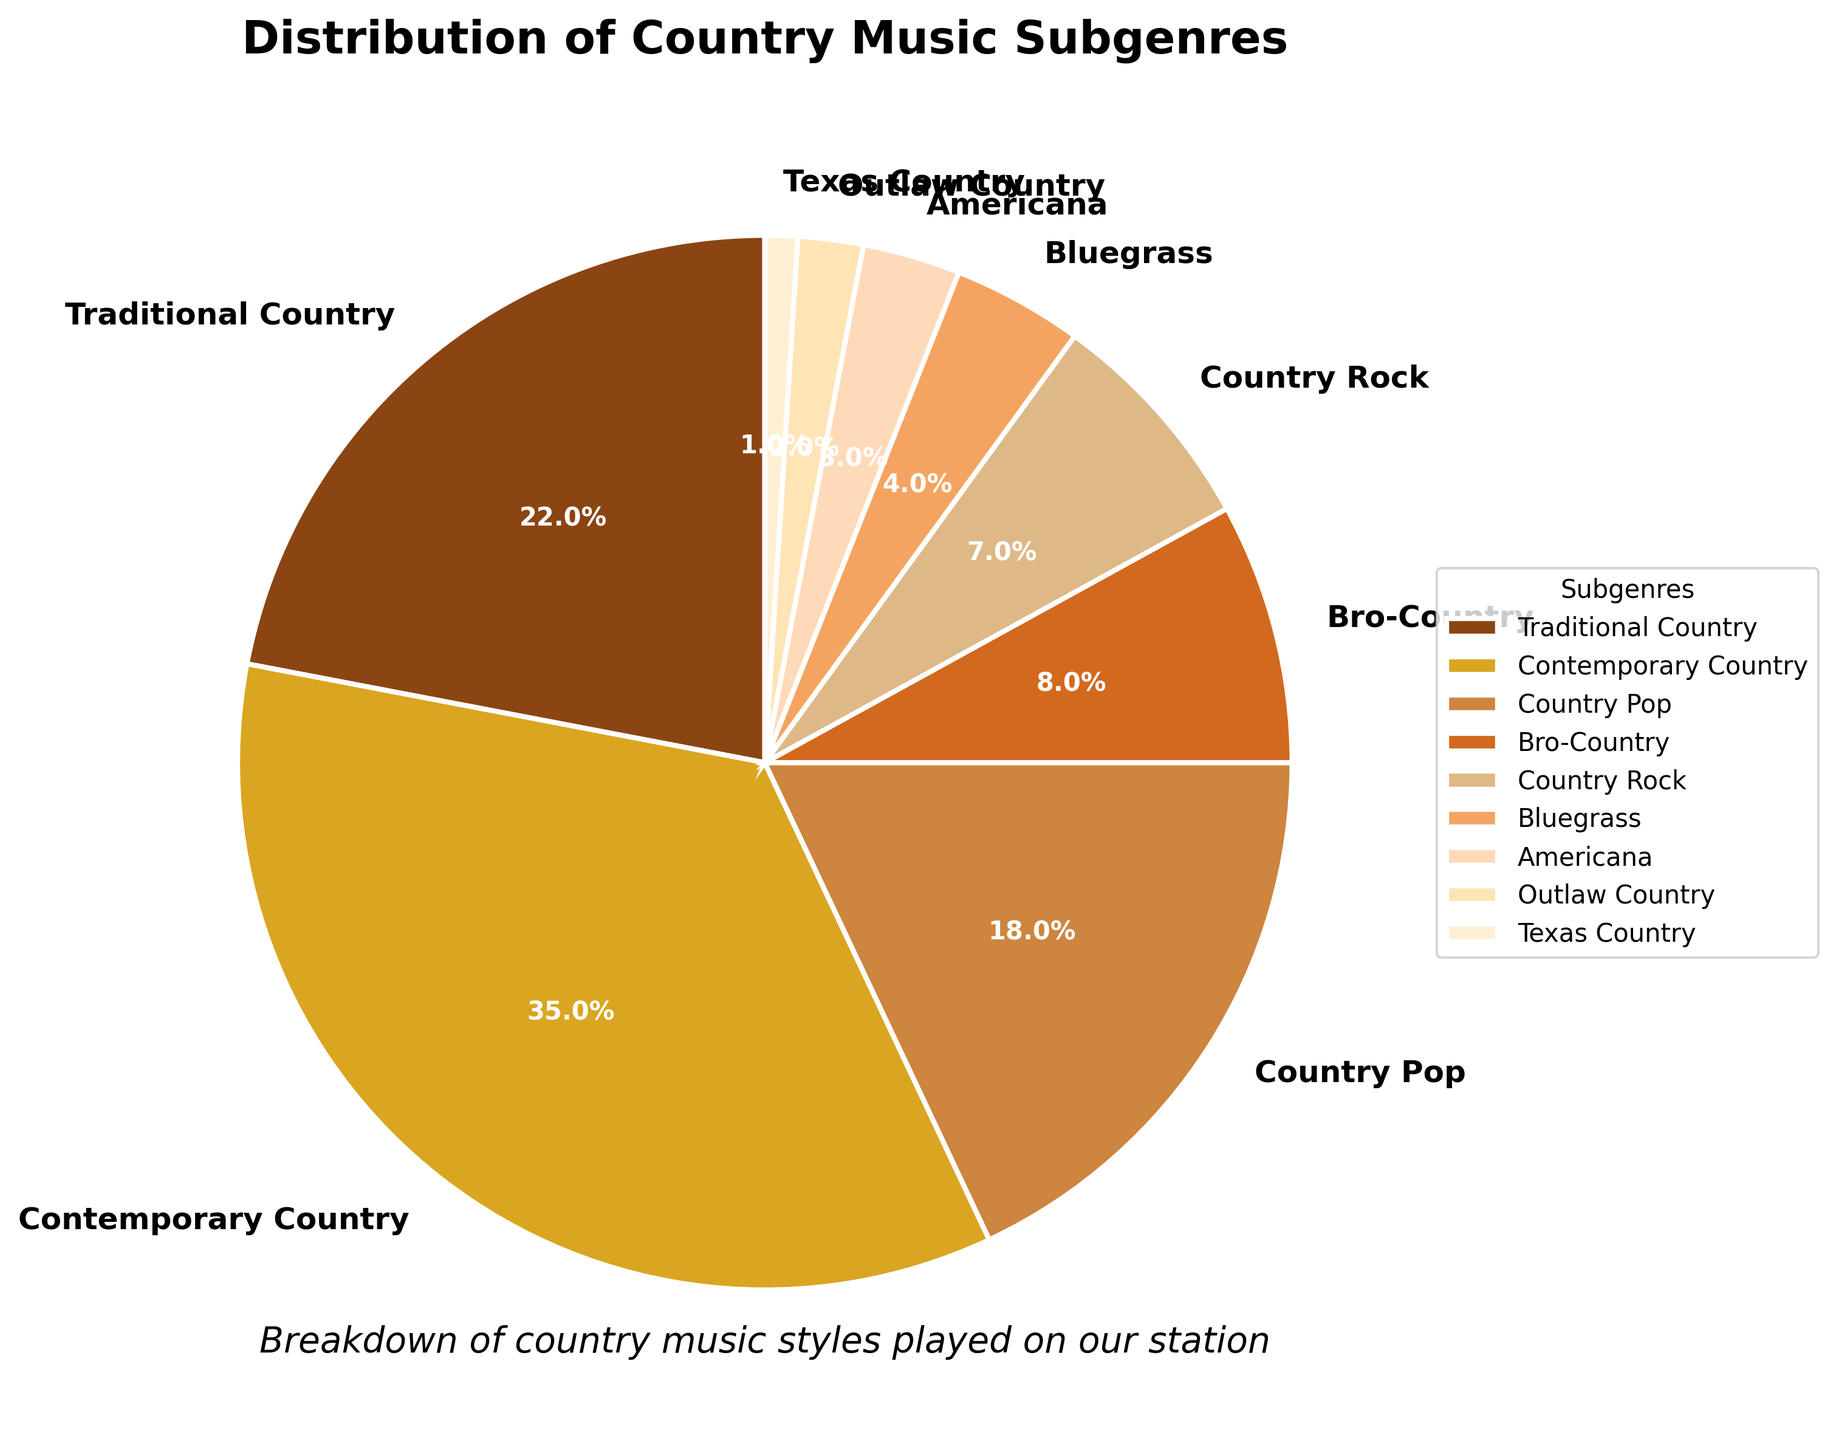What's the most frequently played subgenre on our station? The most frequently played subgenre is the one with the highest percentage slice in the pie chart. The largest slice is labeled as Contemporary Country with 35%.
Answer: Contemporary Country What is the sum of percentages for the three least played subgenres? Identify the three smallest segments of the pie chart, which are Texas Country (1%), Outlaw Country (2%), and Americana (3%). Add these percentages: 1% + 2% + 3% = 6%.
Answer: 6% How much more frequently is Country Pop played compared to Bluegrass? Find the percentages for Country Pop (18%) and Bluegrass (4%). Subtract the smaller from the larger: 18% - 4% = 14%.
Answer: 14% Which subgenre has the closest percentage to Traditional Country? Compare the percentages: Traditional Country (22%) is close to Country Pop (18%). Calculate the difference: 22% - 18% = 4%.
Answer: Country Pop If the station decided to add more Texas Country to have it make up 4% of the playlist, which other subgenre should be reduced to keep the total percentage at 100%? If Texas Country's percentage increases by 3% (from 1% to 4%), another subgenre must be reduced by 3%. Traditional Country (22%) and Country Pop (18%) are the closest larger segments. Reducing Country Pop by 3%, it would go from 18% to 15%.
Answer: Country Pop What fraction of the station’s content is either Traditional Country or Contemporary Country? Add the percentages for Traditional Country (22%) and Contemporary Country (35%): 22% + 35% = 57%. Convert to fraction: 57/100 = 57%.
Answer: 57% How does the percentage of Bro-Country compare with that of Country Rock? Look at the percentages: Bro-Country (8%) and Country Rock (7%). Bro-Country is greater.
Answer: Bro-Country is more Which three subgenres, when combined, make up more than 50% of the station's playlist? Identify subgenres with the largest percentages. Adding Contemporary Country (35%) and Traditional Country (22%) gives 57%, which is already more than 50%.
Answer: Contemporary Country, Traditional Country If we combined the percentages of Bluegrass and Americana, what would their total be? Find the percentages: Bluegrass (4%) and Americana (3%). Add them: 4% + 3% = 7%.
Answer: 7% What is the difference in percentage between the most played subgenre and the least played subgenre? Identify the highest and lowest percentages: Contemporary Country (35%) and Texas Country (1%). Subtract the smallest from the largest: 35% - 1% = 34%.
Answer: 34% 